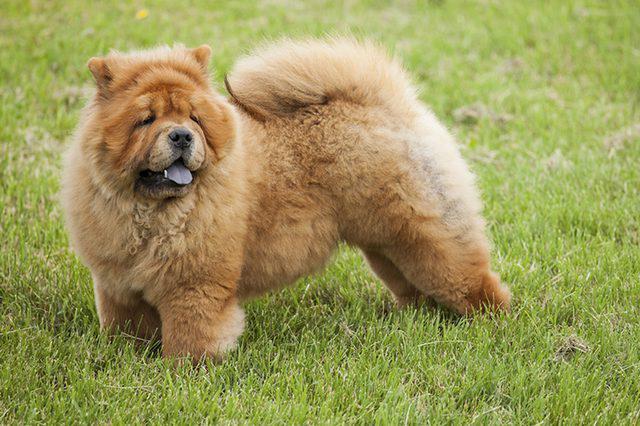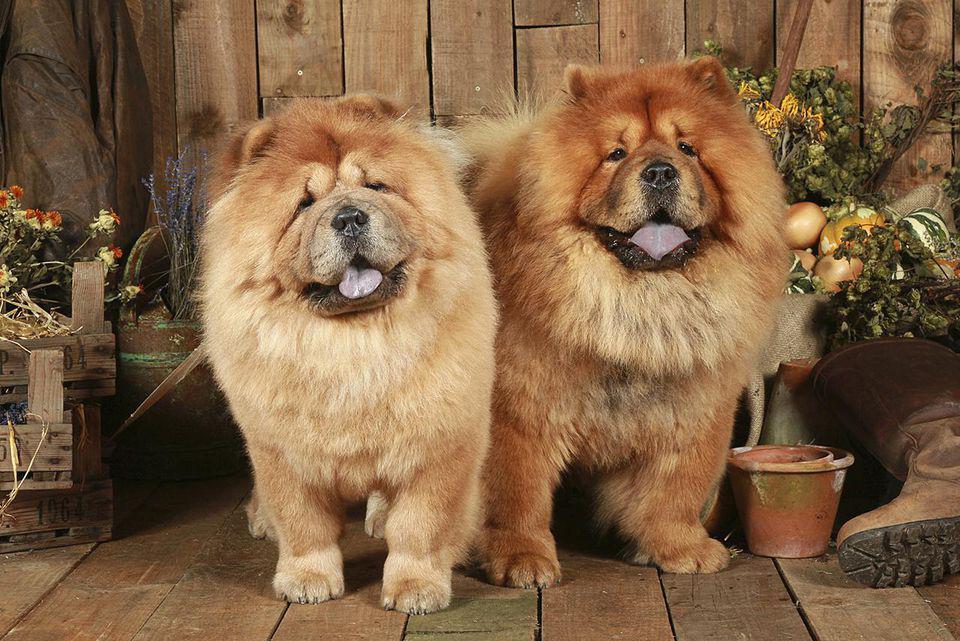The first image is the image on the left, the second image is the image on the right. For the images shown, is this caption "There are just two dogs." true? Answer yes or no. No. The first image is the image on the left, the second image is the image on the right. Considering the images on both sides, is "The left image contains exactly one red-orange chow puppy, and the right image contains exactly one red-orange adult chow." valid? Answer yes or no. No. 